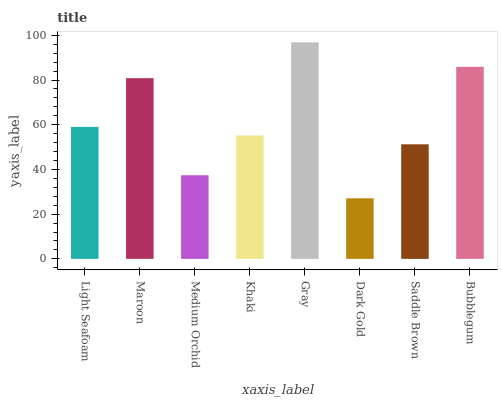Is Dark Gold the minimum?
Answer yes or no. Yes. Is Gray the maximum?
Answer yes or no. Yes. Is Maroon the minimum?
Answer yes or no. No. Is Maroon the maximum?
Answer yes or no. No. Is Maroon greater than Light Seafoam?
Answer yes or no. Yes. Is Light Seafoam less than Maroon?
Answer yes or no. Yes. Is Light Seafoam greater than Maroon?
Answer yes or no. No. Is Maroon less than Light Seafoam?
Answer yes or no. No. Is Light Seafoam the high median?
Answer yes or no. Yes. Is Khaki the low median?
Answer yes or no. Yes. Is Medium Orchid the high median?
Answer yes or no. No. Is Gray the low median?
Answer yes or no. No. 